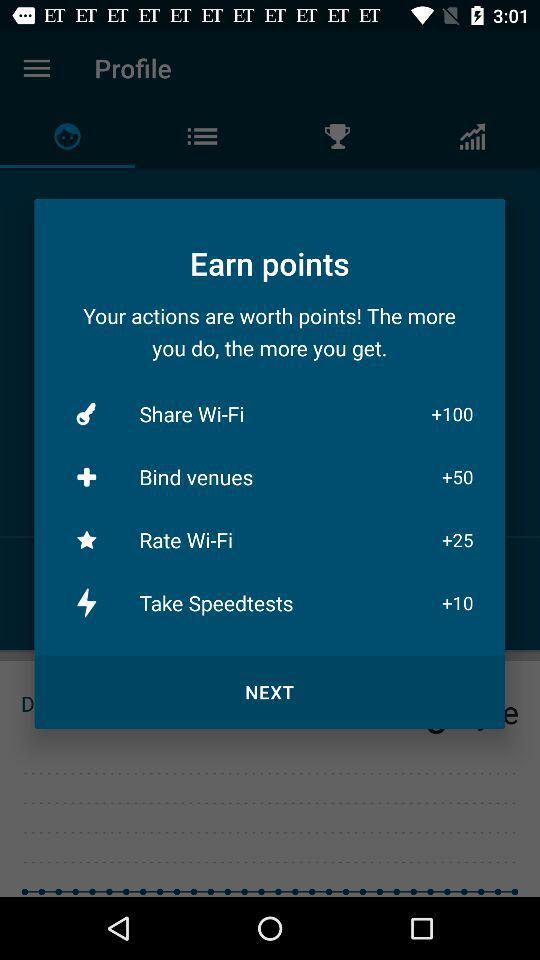How many points are offered for sharing Wi-Fi?
Answer the question using a single word or phrase. 100 